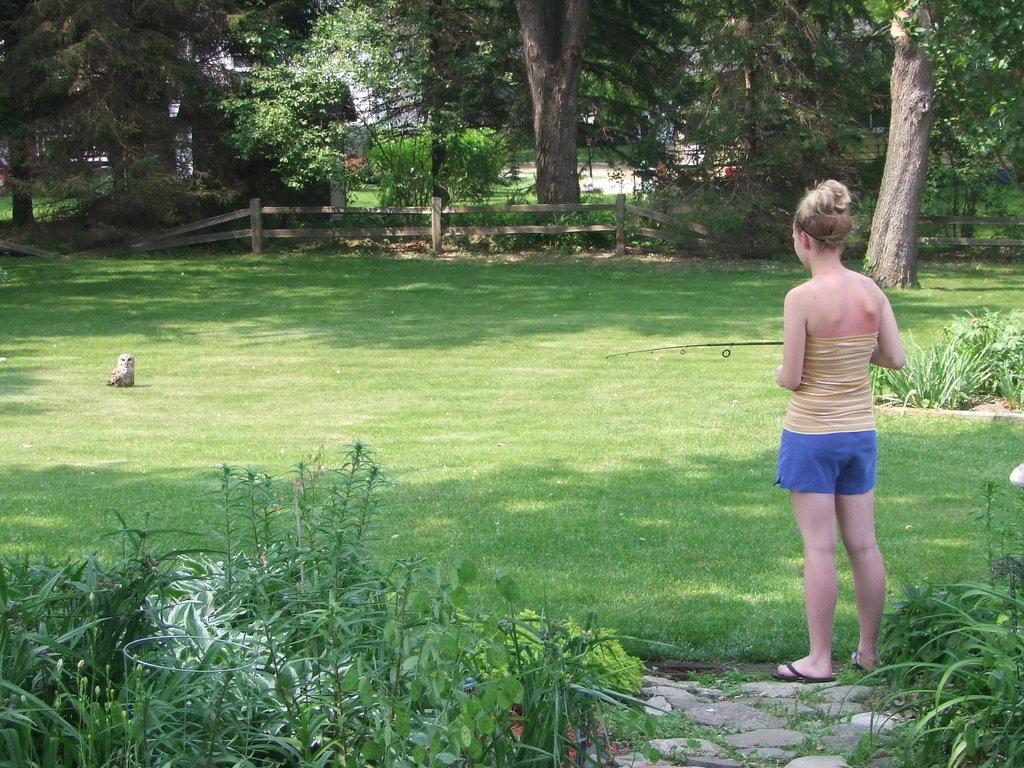How would you summarize this image in a sentence or two? In this picture there is a woman standing and holding the fishing rod. At the back there is a wooden railing and there are buildings and trees. There is a bird on the grass. In the foreground there are plants and stones. 